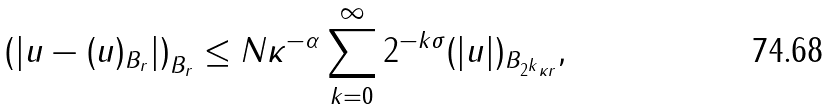Convert formula to latex. <formula><loc_0><loc_0><loc_500><loc_500>\left ( | u - ( u ) _ { B _ { r } } | \right ) _ { B _ { r } } \leq N \kappa ^ { - \alpha } \sum _ { k = 0 } ^ { \infty } 2 ^ { - k \sigma } ( | u | ) _ { B _ { 2 ^ { k } \kappa r } } ,</formula> 